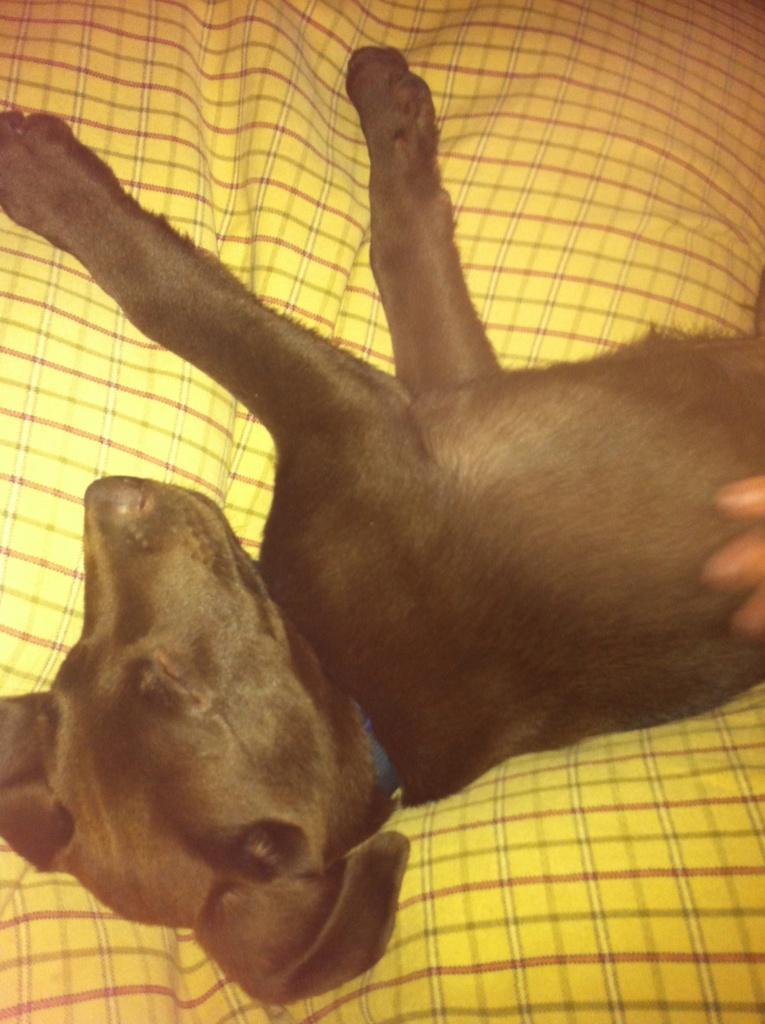Please provide a concise description of this image. There is a black color dog sleeping on a yellow color cloth. 